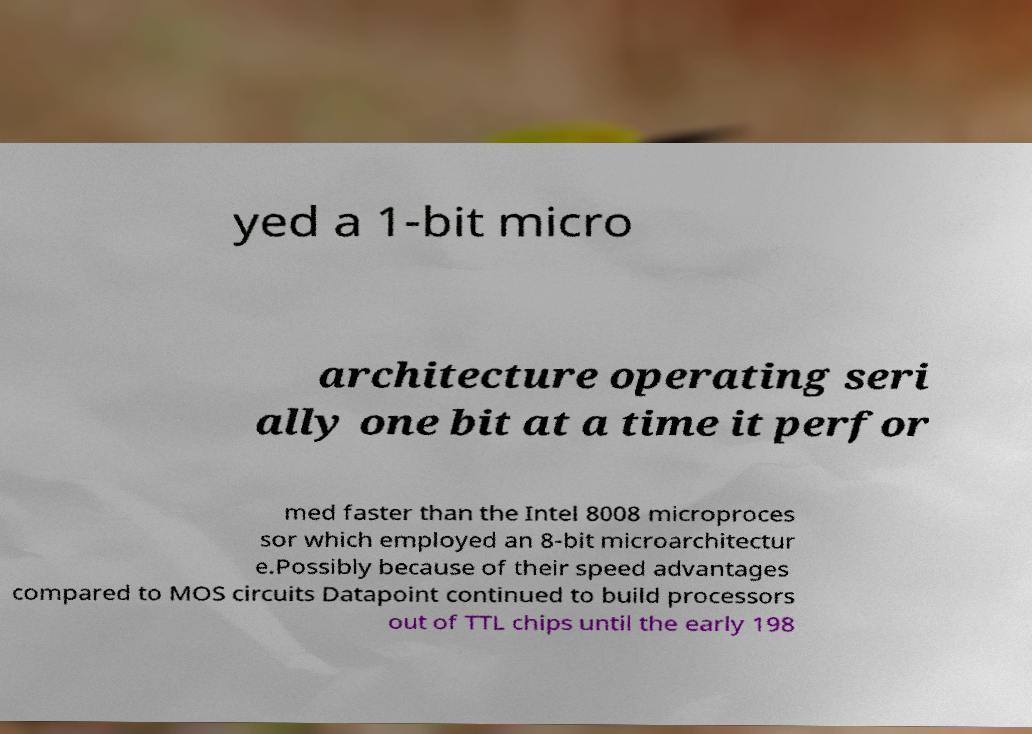Can you read and provide the text displayed in the image?This photo seems to have some interesting text. Can you extract and type it out for me? yed a 1-bit micro architecture operating seri ally one bit at a time it perfor med faster than the Intel 8008 microproces sor which employed an 8-bit microarchitectur e.Possibly because of their speed advantages compared to MOS circuits Datapoint continued to build processors out of TTL chips until the early 198 